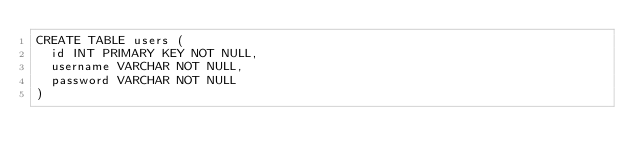Convert code to text. <code><loc_0><loc_0><loc_500><loc_500><_SQL_>CREATE TABLE users (
  id INT PRIMARY KEY NOT NULL,
  username VARCHAR NOT NULL,
  password VARCHAR NOT NULL
)</code> 